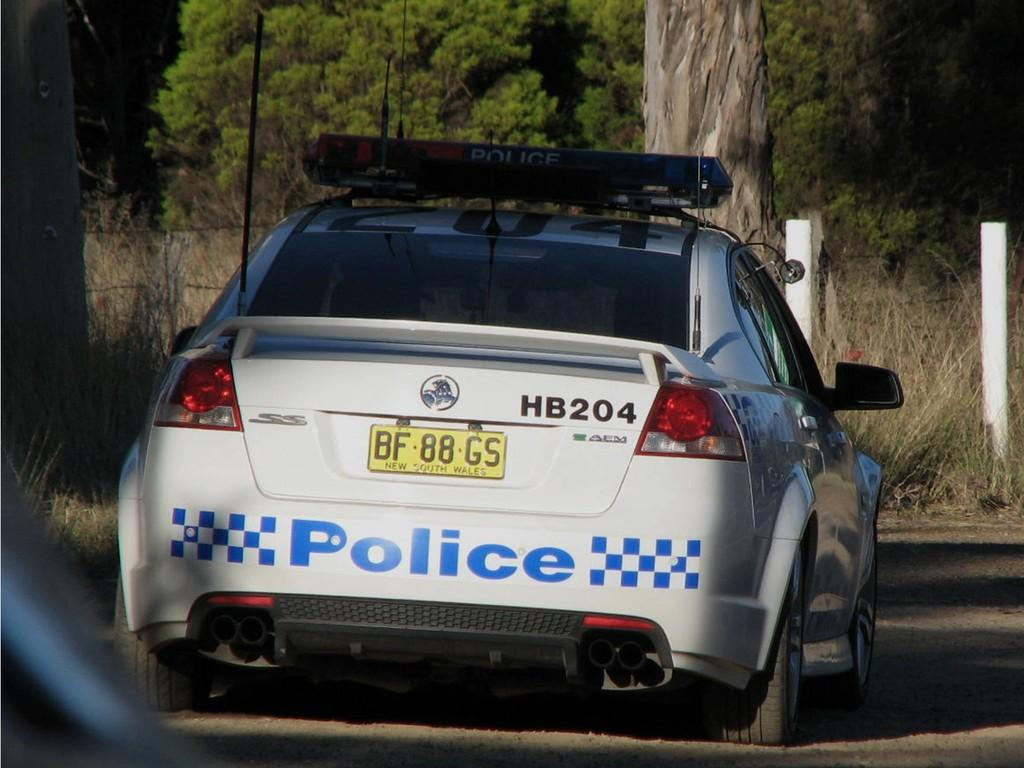<image>
Provide a brief description of the given image. The back of a white and blue checker board pattened police car. 